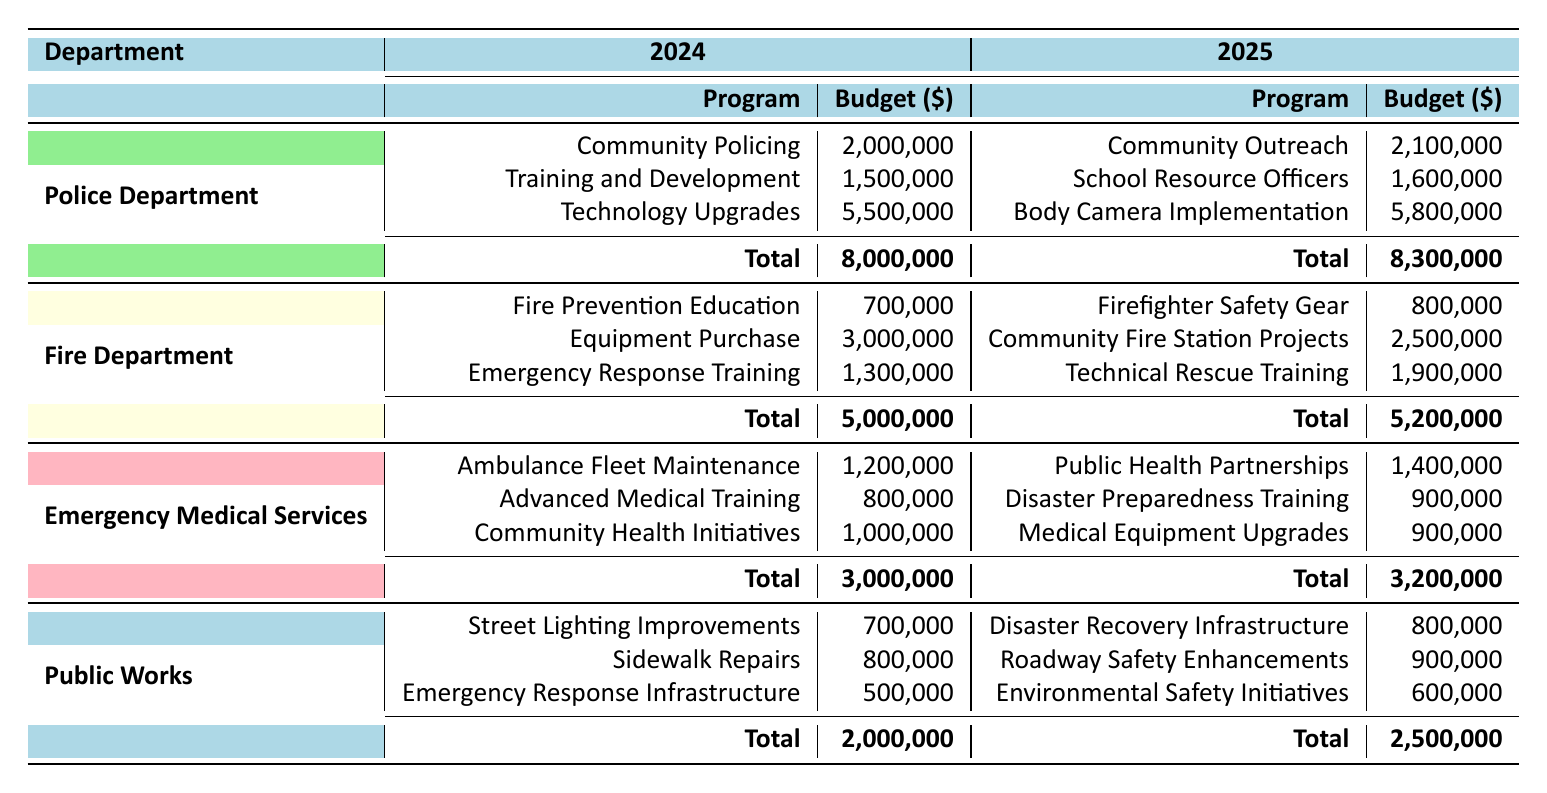What is the total budget for the Police Department in 2024? From the table, in 2024, the Police Department has a total budget of 8,000,000.
Answer: 8,000,000 How much is allocated for Community Fire Station Projects in 2025? According to the table, the allocation for Community Fire Station Projects in 2025 is 2,500,000.
Answer: 2,500,000 Did the budget for the Emergency Medical Services increase from 2024 to 2025? Yes, the budget for Emergency Medical Services increased from 3,000,000 in 2024 to 3,200,000 in 2025.
Answer: Yes What is the combined budget for Public Works in both 2024 and 2025? The combined budget for Public Works is 2,000,000 (2024) + 2,500,000 (2025) = 4,500,000.
Answer: 4,500,000 Is the budget for Technology Upgrades in the Police Department higher than the budget for Equipment Purchase in the Fire Department? Yes, the budget for Technology Upgrades is 5,500,000, while Equipment Purchase is 3,000,000.
Answer: Yes What is the average budget allocated to the Fire Department's programs in 2024? In 2024, the total budget for the Fire Department is 5,000,000, with 3 programs: Fire Prevention Education (700,000), Equipment Purchase (3,000,000), and Emergency Response Training (1,300,000). The average is 5,000,000 / 3 ≈ 1,666,667.
Answer: 1,666,667 Which department received the highest total budget in 2025? In 2025, the Police Department received the highest total budget of 8,300,000 compared to the other departments.
Answer: Police Department How much more funding was allocated to Advanced Medical Training than to Community Health Initiatives in 2024? In 2024, Advanced Medical Training received 800,000, and Community Health Initiatives received 1,000,000. The difference is 1,000,000 - 800,000 = 200,000.
Answer: 200,000 What is the difference in total budget for the Police Department between 2024 and 2025? The difference in the total budget for the Police Department is 8,300,000 (2025) - 8,000,000 (2024) = 300,000.
Answer: 300,000 